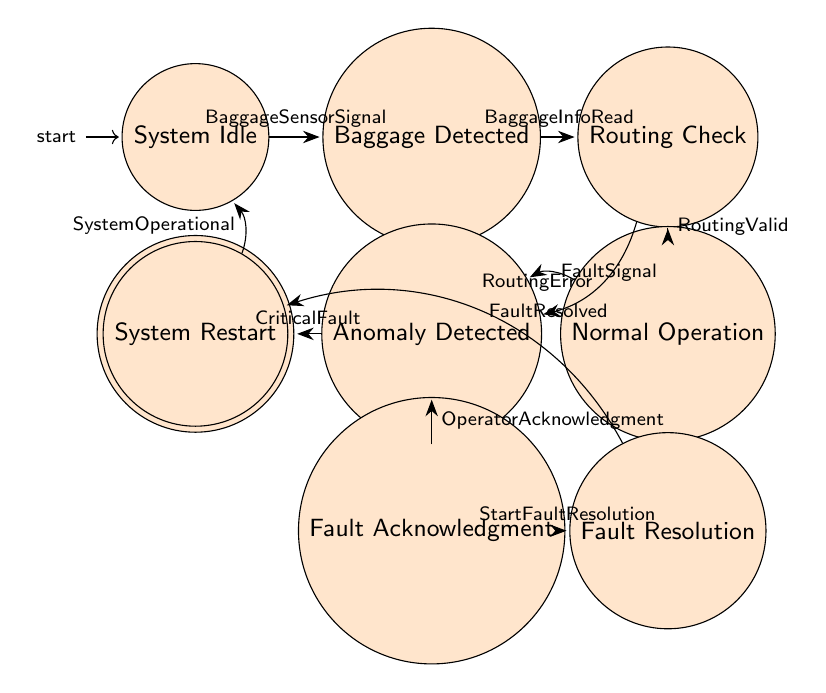What is the initial state of the system? The diagram indicates that the system starts in the "SystemIdle" state, marked as the initial state by the arrow pointing to it.
Answer: SystemIdle How many states are present in the diagram? By counting the different circular nodes in the diagram, we can see there are a total of nine distinct states represented.
Answer: Nine What is the trigger for transitioning from "BaggageDetected" to "RoutingCheck"? The transition from "BaggageDetected" to "RoutingCheck" happens when the trigger "BaggageInfoRead" occurs, as indicated by the labeled arrow between these two states.
Answer: BaggageInfoRead What state does the system enter after acknowledging a fault? Once the fault is acknowledged by the operator, the system will move to the "FaultResolution" state, as indicated by the transition from "FaultAcknowledgment" to "FaultResolution".
Answer: FaultResolution What happens if a critical fault is detected while in "AnomalyDetected"? If a critical fault occurs while in the "AnomalyDetected" state, the system will transition to the "EmergencyStop" state, as marked by the arrow in that direction labeled with "CriticalFault".
Answer: EmergencyStop What is the final state after the system is restarted? After a successful restart, the system transitions back to the "SystemIdle" state, completing the cycle of operations as indicated by the arrow labeled "SystemOperational".
Answer: SystemIdle Identify the action taken during the transition from "RoutingCheck" to "AnomalyDetected". During this transition, when "RoutingError" is triggered, the action taken is to "LogRoutingError," which is indicated by the description along the arrow.
Answer: LogRoutingError From which state does the system transition to "SystemRestart"? The system moves to "SystemRestart" from the "FaultResolution" state after reaching the condition triggered by "FaultResolved". This is shown in the transition from FaultResolution to SystemRestart.
Answer: FaultResolution 